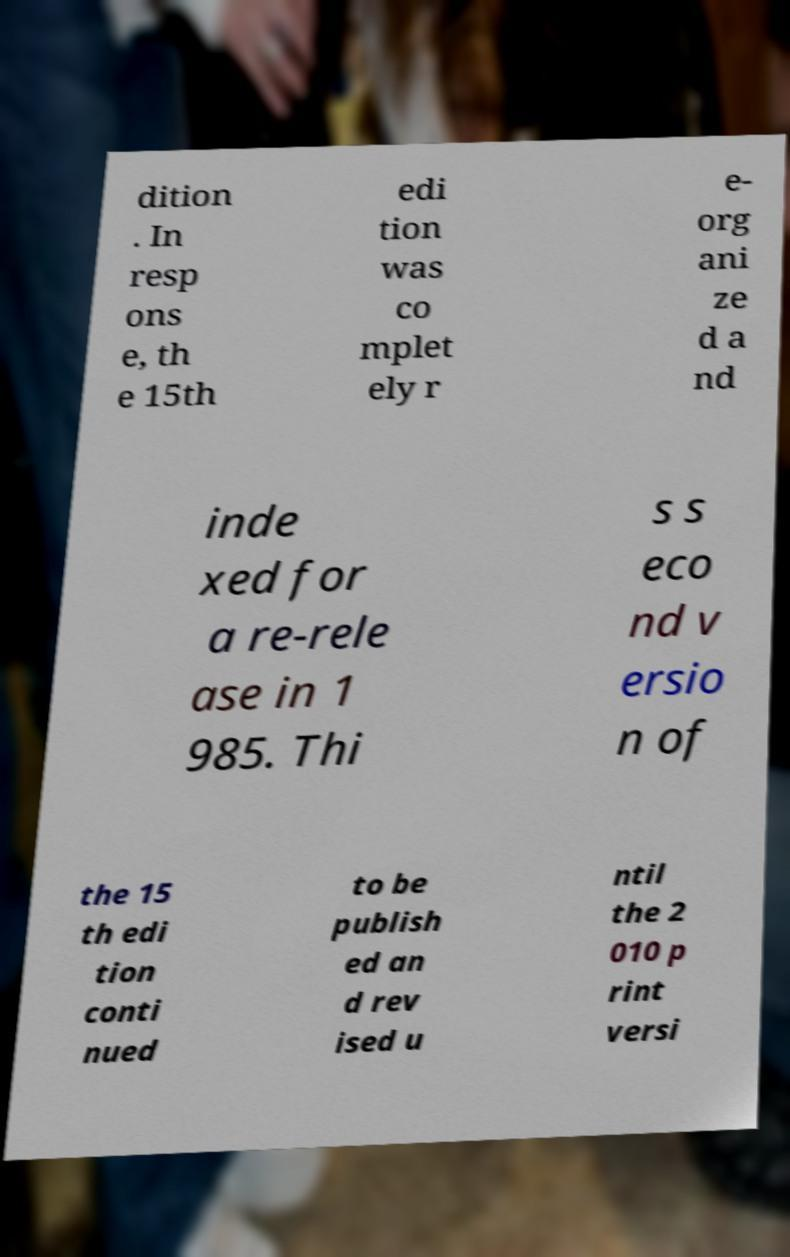What messages or text are displayed in this image? I need them in a readable, typed format. dition . In resp ons e, th e 15th edi tion was co mplet ely r e- org ani ze d a nd inde xed for a re-rele ase in 1 985. Thi s s eco nd v ersio n of the 15 th edi tion conti nued to be publish ed an d rev ised u ntil the 2 010 p rint versi 